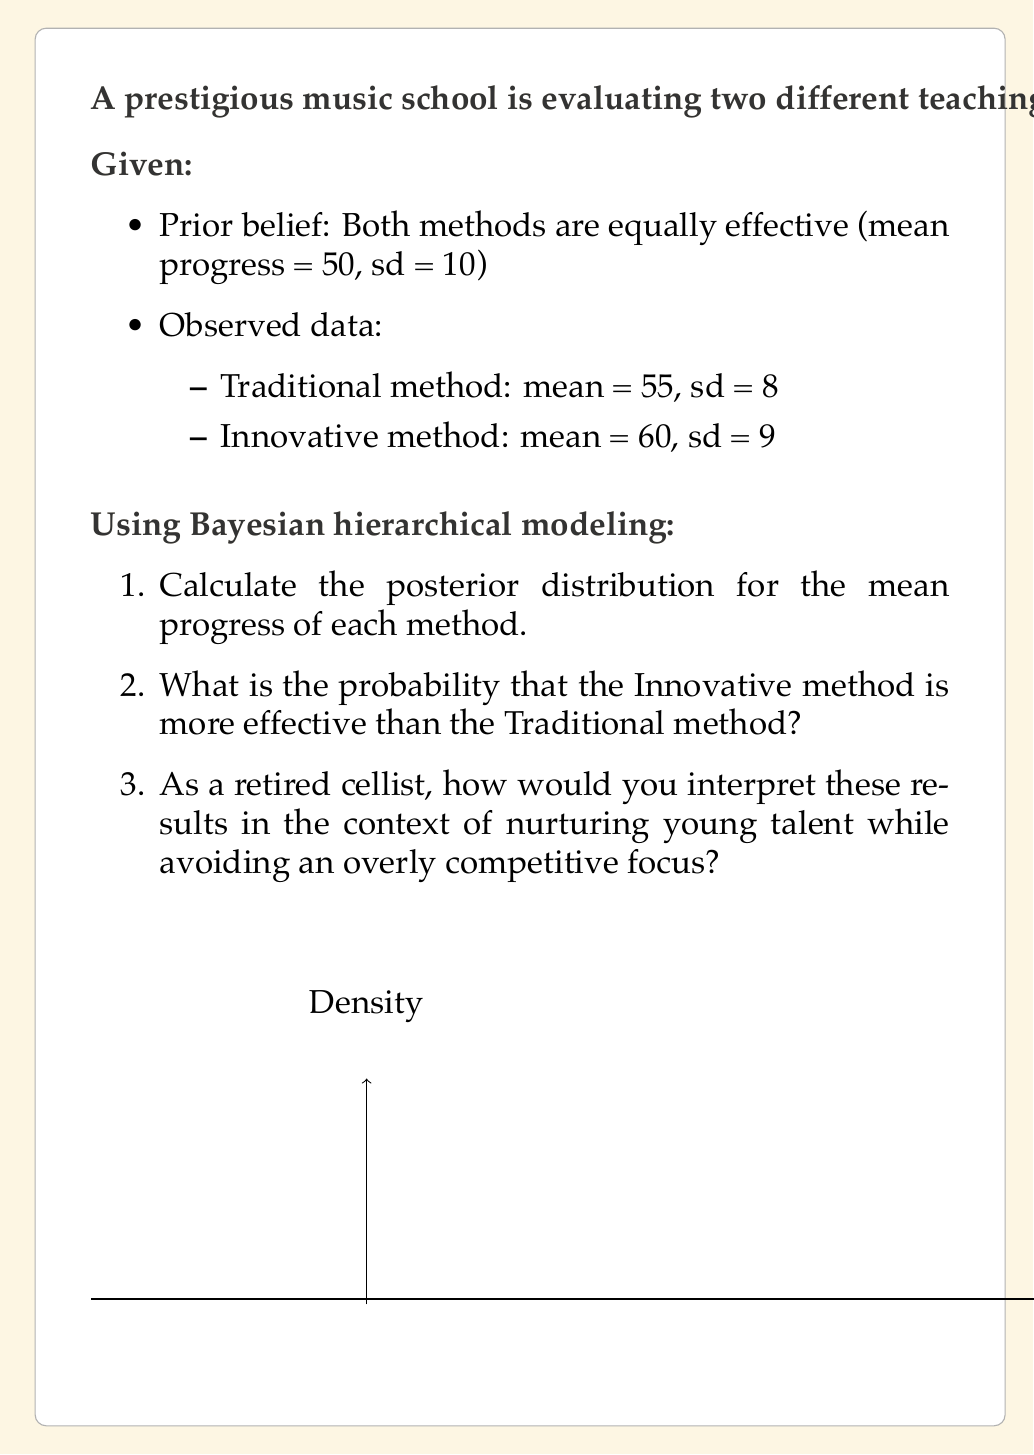Could you help me with this problem? Let's approach this problem step-by-step using Bayesian hierarchical modeling:

1. Calculating the posterior distribution for each method:

We'll use the normal-normal model, where the prior and likelihood are both normal distributions. The posterior distribution will also be normal.

For the Traditional method:
Prior: $\mu_0 = 50$, $\sigma_0 = 10$
Likelihood: $\bar{x} = 55$, $s = 8$, $n = 50$

The posterior mean is given by:

$$\mu_1 = \frac{\frac{\mu_0}{\sigma_0^2} + \frac{n\bar{x}}{s^2}}{\frac{1}{\sigma_0^2} + \frac{n}{s^2}}$$

$$\mu_1 = \frac{\frac{50}{10^2} + \frac{50 \cdot 55}{8^2}}{\frac{1}{10^2} + \frac{50}{8^2}} \approx 54.84$$

The posterior standard deviation is:

$$\sigma_1 = \sqrt{\frac{1}{\frac{1}{\sigma_0^2} + \frac{n}{s^2}}} \approx 1.12$$

For the Innovative method:
Prior: $\mu_0 = 50$, $\sigma_0 = 10$
Likelihood: $\bar{x} = 60$, $s = 9$, $n = 50$

Using the same formulas:

$$\mu_1 \approx 59.70$$
$$\sigma_1 \approx 1.26$$

2. Probability that the Innovative method is more effective:

We need to calculate $P(\mu_{Innovative} > \mu_{Traditional})$. This is equivalent to calculating $P(\mu_{Innovative} - \mu_{Traditional} > 0)$.

The difference between two normal distributions is also normally distributed:

$$\mu_{diff} = 59.70 - 54.84 = 4.86$$
$$\sigma_{diff} = \sqrt{1.26^2 + 1.12^2} = 1.68$$

The probability is:

$$P(\mu_{Innovative} - \mu_{Traditional} > 0) = 1 - \Phi(\frac{0 - 4.86}{1.68}) \approx 0.9982$$

Where $\Phi$ is the cumulative distribution function of the standard normal distribution.

3. Interpretation:

As a retired cellist, these results suggest that the Innovative method appears to be more effective in improving student progress. However, it's crucial to remember that while statistical analysis is valuable, it shouldn't be the sole focus in nurturing young talent. 

The high probability (99.82%) of the Innovative method being more effective is significant, but we should consider other factors such as individual student preferences, long-term sustainability of progress, and the holistic development of musicians. 

It's important to use these results as a guide for improvement rather than a tool for competition. Both methods show positive progress, and the goal should be to understand why the Innovative method seems more effective and how elements of it could be incorporated into traditional teaching to benefit all students.
Answer: Posterior distributions: Traditional method $N(54.84, 1.12^2)$, Innovative method $N(59.70, 1.26^2)$. Probability Innovative is more effective: 0.9982. Interpretation: Results favor Innovative method, but consider holistic development and avoid over-emphasis on competition. 